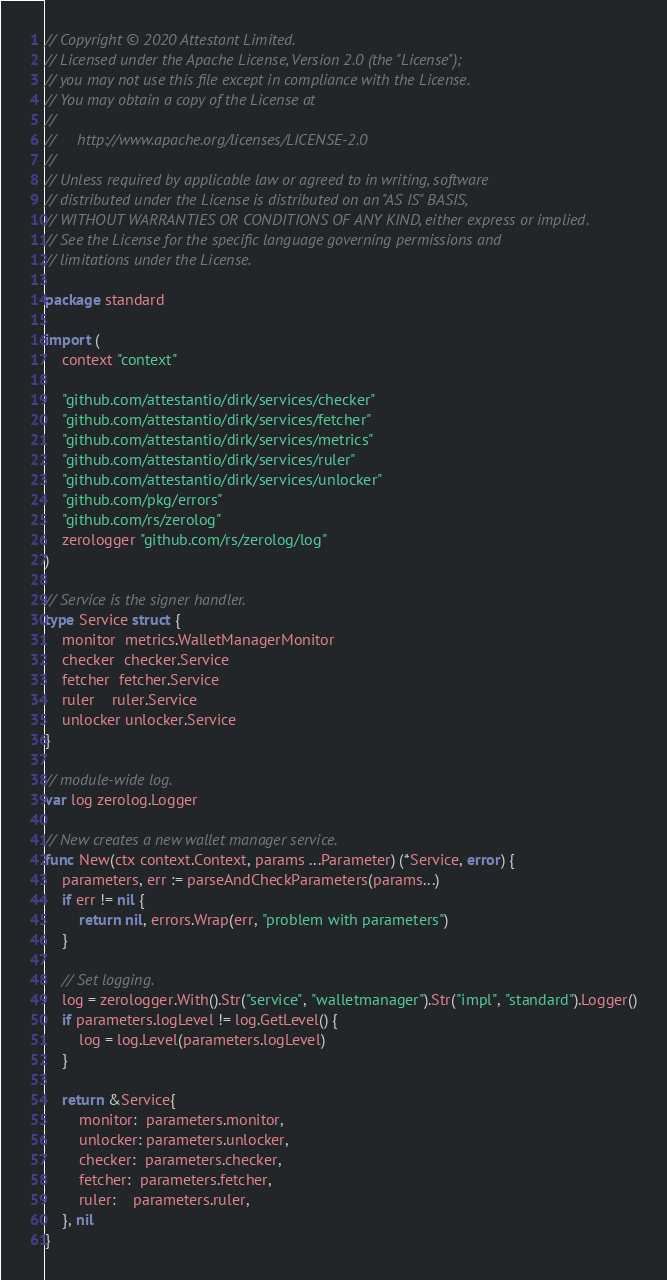<code> <loc_0><loc_0><loc_500><loc_500><_Go_>// Copyright © 2020 Attestant Limited.
// Licensed under the Apache License, Version 2.0 (the "License");
// you may not use this file except in compliance with the License.
// You may obtain a copy of the License at
//
//     http://www.apache.org/licenses/LICENSE-2.0
//
// Unless required by applicable law or agreed to in writing, software
// distributed under the License is distributed on an "AS IS" BASIS,
// WITHOUT WARRANTIES OR CONDITIONS OF ANY KIND, either express or implied.
// See the License for the specific language governing permissions and
// limitations under the License.

package standard

import (
	context "context"

	"github.com/attestantio/dirk/services/checker"
	"github.com/attestantio/dirk/services/fetcher"
	"github.com/attestantio/dirk/services/metrics"
	"github.com/attestantio/dirk/services/ruler"
	"github.com/attestantio/dirk/services/unlocker"
	"github.com/pkg/errors"
	"github.com/rs/zerolog"
	zerologger "github.com/rs/zerolog/log"
)

// Service is the signer handler.
type Service struct {
	monitor  metrics.WalletManagerMonitor
	checker  checker.Service
	fetcher  fetcher.Service
	ruler    ruler.Service
	unlocker unlocker.Service
}

// module-wide log.
var log zerolog.Logger

// New creates a new wallet manager service.
func New(ctx context.Context, params ...Parameter) (*Service, error) {
	parameters, err := parseAndCheckParameters(params...)
	if err != nil {
		return nil, errors.Wrap(err, "problem with parameters")
	}

	// Set logging.
	log = zerologger.With().Str("service", "walletmanager").Str("impl", "standard").Logger()
	if parameters.logLevel != log.GetLevel() {
		log = log.Level(parameters.logLevel)
	}

	return &Service{
		monitor:  parameters.monitor,
		unlocker: parameters.unlocker,
		checker:  parameters.checker,
		fetcher:  parameters.fetcher,
		ruler:    parameters.ruler,
	}, nil
}
</code> 